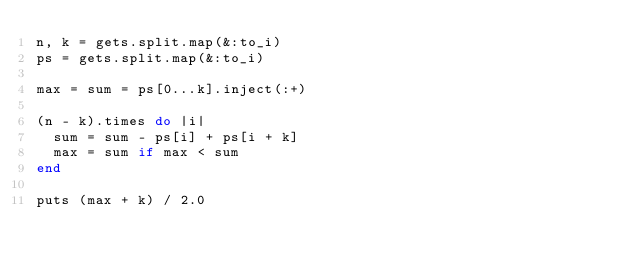Convert code to text. <code><loc_0><loc_0><loc_500><loc_500><_Ruby_>n, k = gets.split.map(&:to_i)
ps = gets.split.map(&:to_i)

max = sum = ps[0...k].inject(:+)

(n - k).times do |i|
  sum = sum - ps[i] + ps[i + k]
  max = sum if max < sum
end

puts (max + k) / 2.0</code> 